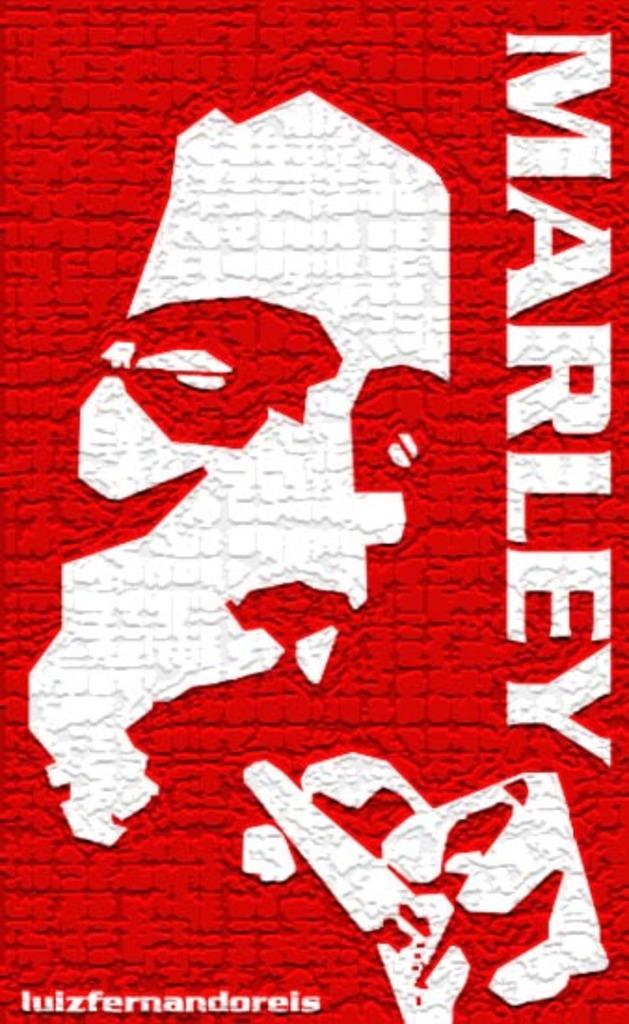<image>
Render a clear and concise summary of the photo. Red sign that shows a man's face and the name "MARLEY". 